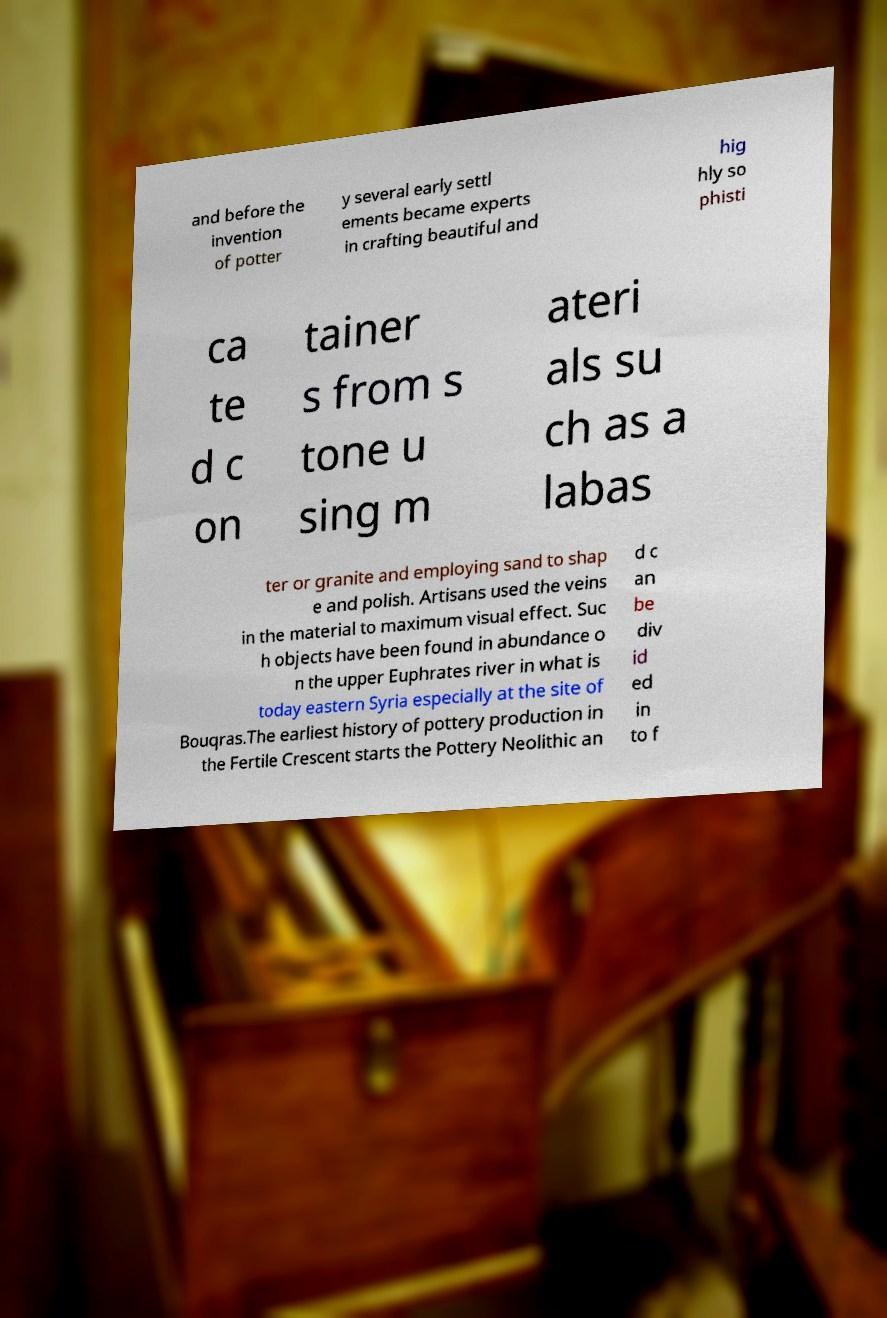Could you assist in decoding the text presented in this image and type it out clearly? and before the invention of potter y several early settl ements became experts in crafting beautiful and hig hly so phisti ca te d c on tainer s from s tone u sing m ateri als su ch as a labas ter or granite and employing sand to shap e and polish. Artisans used the veins in the material to maximum visual effect. Suc h objects have been found in abundance o n the upper Euphrates river in what is today eastern Syria especially at the site of Bouqras.The earliest history of pottery production in the Fertile Crescent starts the Pottery Neolithic an d c an be div id ed in to f 